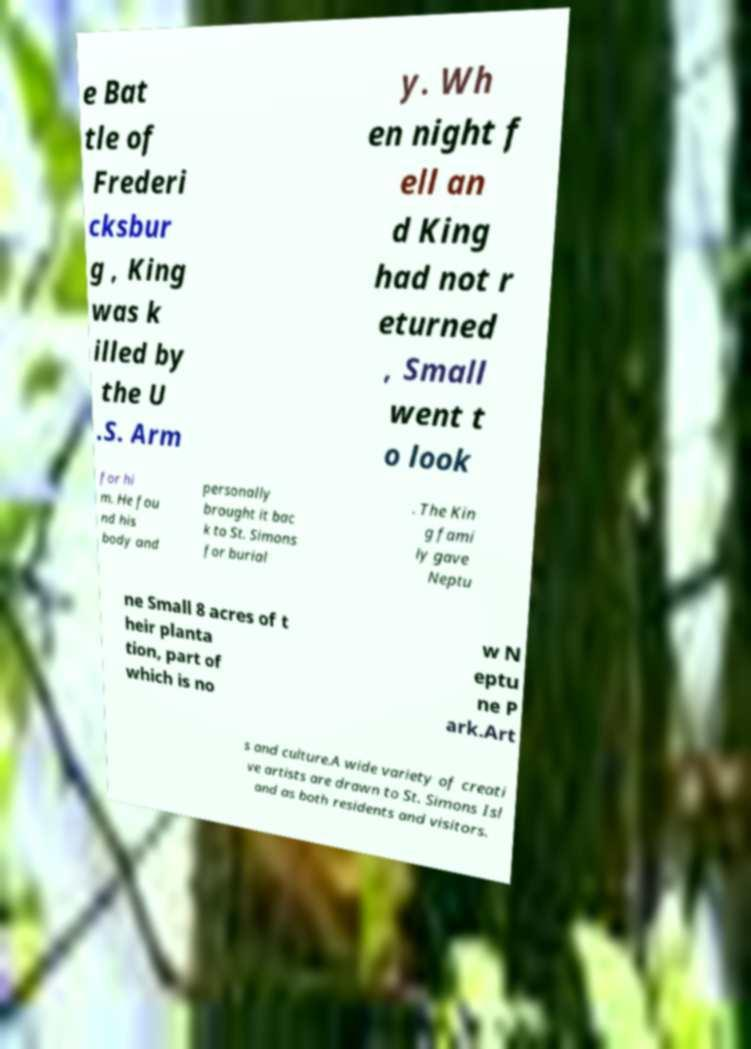Please identify and transcribe the text found in this image. e Bat tle of Frederi cksbur g , King was k illed by the U .S. Arm y. Wh en night f ell an d King had not r eturned , Small went t o look for hi m. He fou nd his body and personally brought it bac k to St. Simons for burial . The Kin g fami ly gave Neptu ne Small 8 acres of t heir planta tion, part of which is no w N eptu ne P ark.Art s and culture.A wide variety of creati ve artists are drawn to St. Simons Isl and as both residents and visitors. 